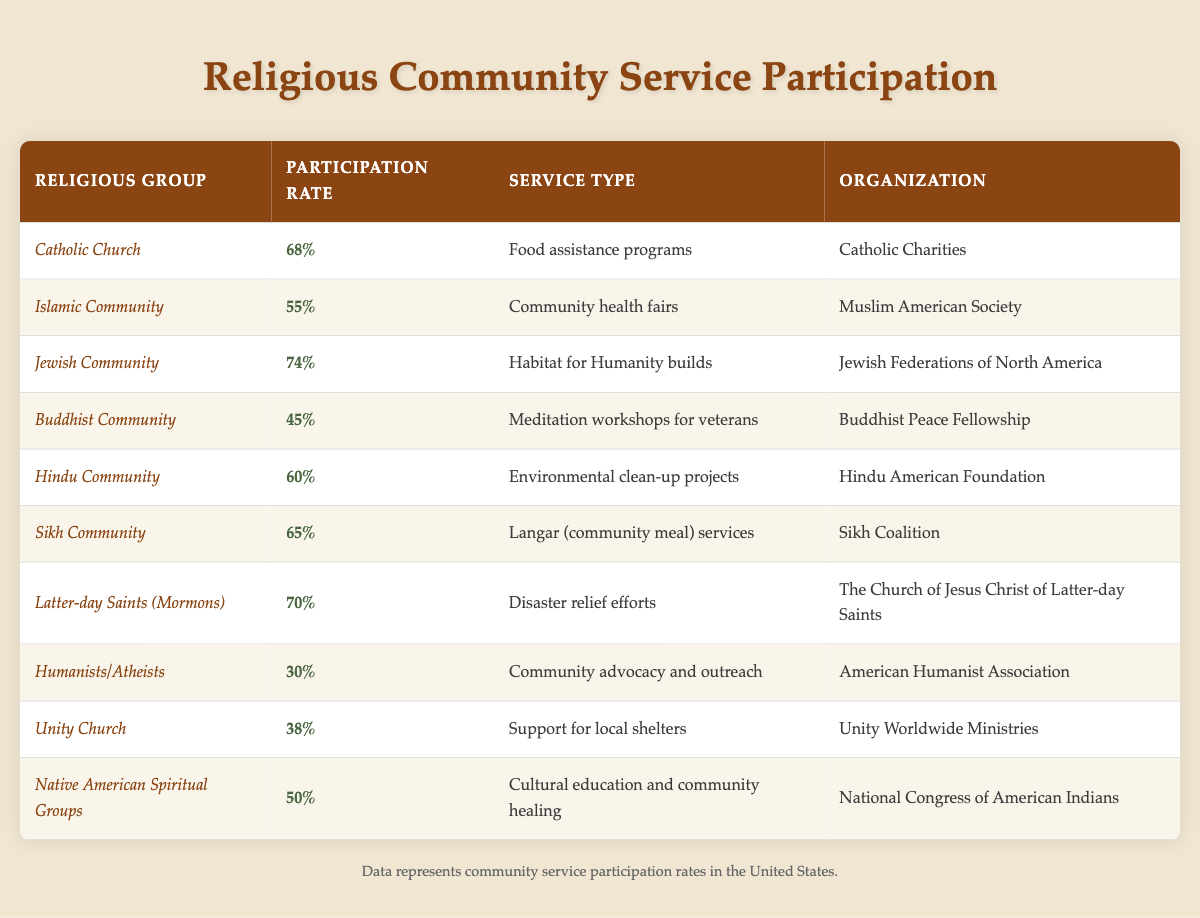What is the participation rate of the Jewish Community? The table shows that the participation rate for the Jewish Community is listed directly next to it, which is 74%.
Answer: 74% Which religious group has the lowest participation rate in community service initiatives? By examining the participation rates in the table, the lowest rate is found to be 30% for Humanists/Atheists.
Answer: 30% What is the average participation rate of the religious groups listed? To find the average, sum the participation rates of all groups (68 + 55 + 74 + 45 + 60 + 65 + 70 + 30 + 38 + 50 = 675). Then divide by the total number of groups (10), resulting in an average of 675/10 = 67.5%.
Answer: 67.5% Is the participation rate of the Sikh Community higher than that of the Buddhist Community? The Sikh Community's participation rate is 65%, while the Buddhist Community's rate is 45%. Since 65% is greater than 45%, the assertion is true.
Answer: Yes Which two religious groups participate in service types related to food? From the table, Catholic Church (Food assistance programs) and Sikh Community (Langar community meal services) are the two groups.
Answer: Catholic Church and Sikh Community What is the difference in participation rates between the Latter-day Saints (Mormons) and the Hindu Community? The Latter-day Saints have a participation rate of 70%, and the Hindu Community has 60%. The difference is 70 - 60 = 10%.
Answer: 10% How many religious groups have a participation rate of 50% or higher? Looking through the table, the groups with 50% or higher participation rates are: Catholic Church, Islamic Community, Jewish Community, Hindu Community, Sikh Community, Latter-day Saints, and Native American Spiritual Groups. Counting these gives a total of 7 groups.
Answer: 7 Are there more religious groups with participation rates below 50% than those above? The groups below 50% are Humanists/Atheists (30%), Unity Church (38%), and Buddhist Community (45%), totaling 3 groups. The groups above 50% are Catholic Church, Islamic Community, Jewish Community, Hindu Community, Sikh Community, Latter-day Saints, and Native American Spiritual Groups, totaling 7 groups. Therefore, the number above is greater.
Answer: No What type of community service is provided by the organization "Buddhist Peace Fellowship"? According to the table, the Buddhist Peace Fellowship provides meditation workshops for veterans.
Answer: Meditation workshops for veterans 